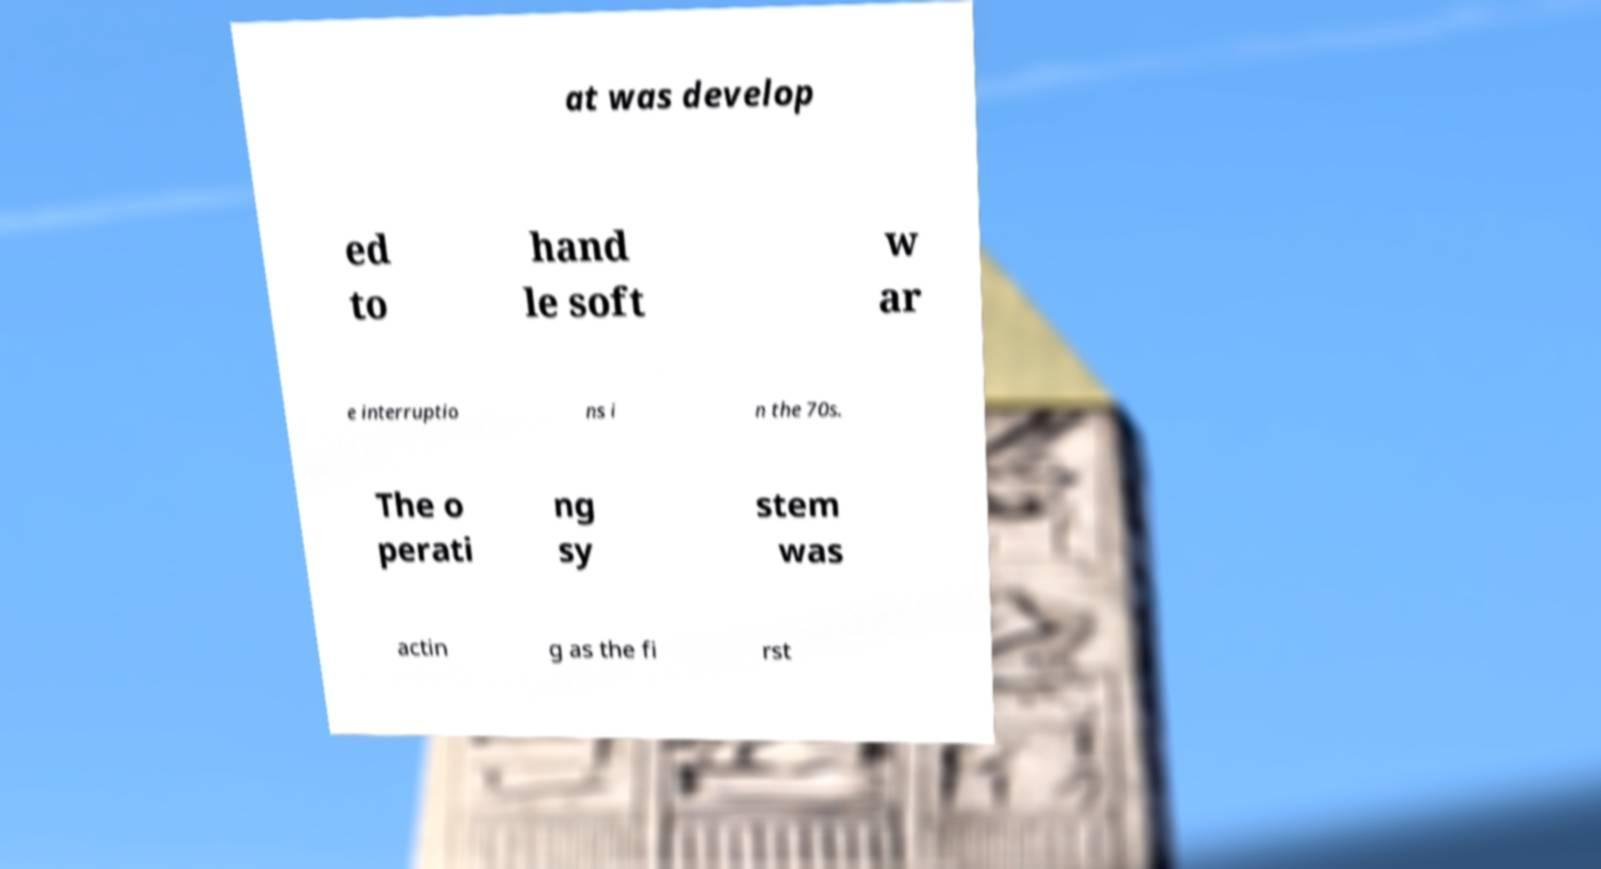Please read and relay the text visible in this image. What does it say? at was develop ed to hand le soft w ar e interruptio ns i n the 70s. The o perati ng sy stem was actin g as the fi rst 